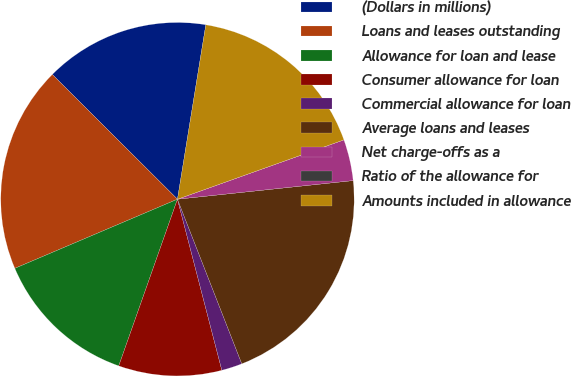Convert chart to OTSL. <chart><loc_0><loc_0><loc_500><loc_500><pie_chart><fcel>(Dollars in millions)<fcel>Loans and leases outstanding<fcel>Allowance for loan and lease<fcel>Consumer allowance for loan<fcel>Commercial allowance for loan<fcel>Average loans and leases<fcel>Net charge-offs as a<fcel>Ratio of the allowance for<fcel>Amounts included in allowance<nl><fcel>15.09%<fcel>18.87%<fcel>13.21%<fcel>9.43%<fcel>1.89%<fcel>20.75%<fcel>3.77%<fcel>0.0%<fcel>16.98%<nl></chart> 